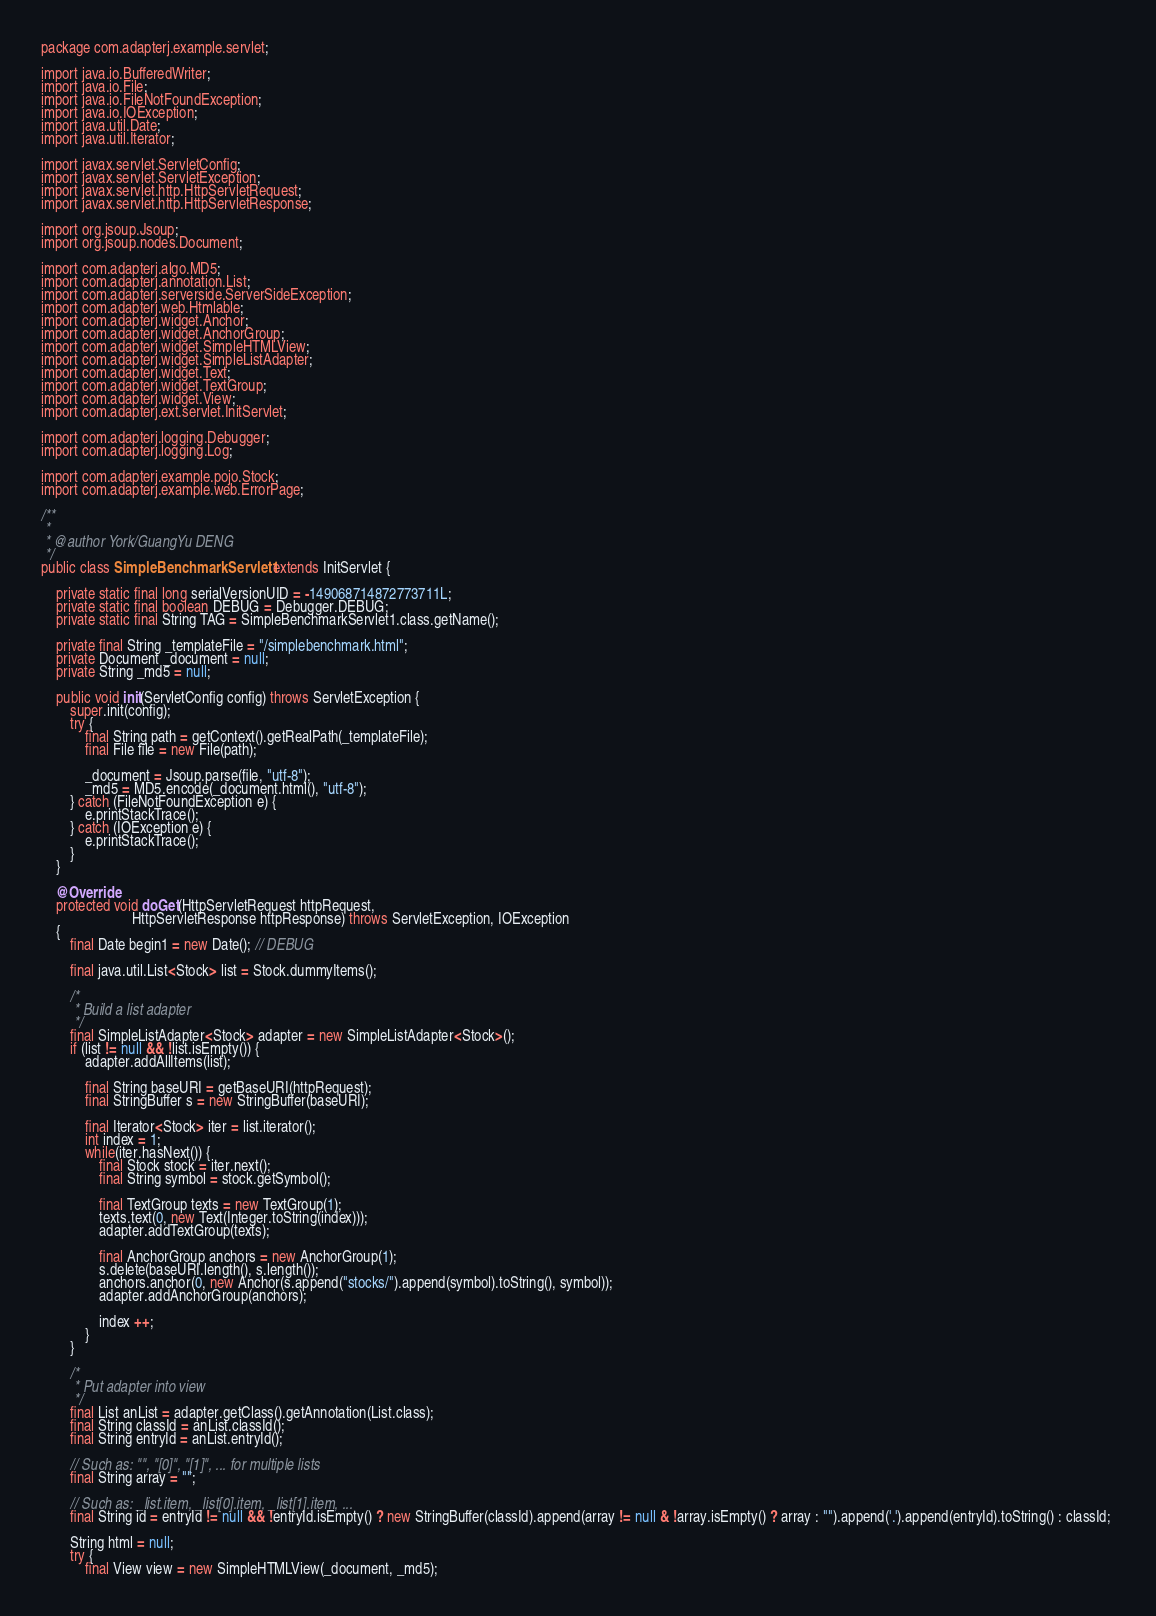Convert code to text. <code><loc_0><loc_0><loc_500><loc_500><_Java_>package com.adapterj.example.servlet;

import java.io.BufferedWriter;
import java.io.File;
import java.io.FileNotFoundException;
import java.io.IOException;
import java.util.Date;
import java.util.Iterator;

import javax.servlet.ServletConfig;
import javax.servlet.ServletException;
import javax.servlet.http.HttpServletRequest;
import javax.servlet.http.HttpServletResponse;

import org.jsoup.Jsoup;
import org.jsoup.nodes.Document;

import com.adapterj.algo.MD5;
import com.adapterj.annotation.List;
import com.adapterj.serverside.ServerSideException;
import com.adapterj.web.Htmlable;
import com.adapterj.widget.Anchor;
import com.adapterj.widget.AnchorGroup;
import com.adapterj.widget.SimpleHTMLView;
import com.adapterj.widget.SimpleListAdapter;
import com.adapterj.widget.Text;
import com.adapterj.widget.TextGroup;
import com.adapterj.widget.View;
import com.adapterj.ext.servlet.InitServlet;

import com.adapterj.logging.Debugger;
import com.adapterj.logging.Log;

import com.adapterj.example.pojo.Stock;
import com.adapterj.example.web.ErrorPage;

/**
 * 
 * @author York/GuangYu DENG
 */
public class SimpleBenchmarkServlet1 extends InitServlet {

	private static final long serialVersionUID = -149068714872773711L;
	private static final boolean DEBUG = Debugger.DEBUG;
    private static final String TAG = SimpleBenchmarkServlet1.class.getName();

    private final String _templateFile = "/simplebenchmark.html";
    private Document _document = null;
    private String _md5 = null;

	public void init(ServletConfig config) throws ServletException {
		super.init(config);
		try {
			final String path = getContext().getRealPath(_templateFile);
			final File file = new File(path);
			
			_document = Jsoup.parse(file, "utf-8");
			_md5 = MD5.encode(_document.html(), "utf-8");
		} catch (FileNotFoundException e) {
			e.printStackTrace();
		} catch (IOException e) {
			e.printStackTrace();
		}
	}

	@Override
	protected void doGet(HttpServletRequest httpRequest, 
						 HttpServletResponse httpResponse) throws ServletException, IOException 
	{
		final Date begin1 = new Date(); // DEBUG

		final java.util.List<Stock> list = Stock.dummyItems();

		/*
		 * Build a list adapter 
		 */
		final SimpleListAdapter<Stock> adapter = new SimpleListAdapter<Stock>();
		if (list != null && !list.isEmpty()) {
			adapter.addAllItems(list);
			
			final String baseURI = getBaseURI(httpRequest);
			final StringBuffer s = new StringBuffer(baseURI);
			
			final Iterator<Stock> iter = list.iterator();
			int index = 1;
			while(iter.hasNext()) {
				final Stock stock = iter.next();
				final String symbol = stock.getSymbol();
				
				final TextGroup texts = new TextGroup(1);
				texts.text(0, new Text(Integer.toString(index)));
				adapter.addTextGroup(texts);
				
				final AnchorGroup anchors = new AnchorGroup(1);
				s.delete(baseURI.length(), s.length());
				anchors.anchor(0, new Anchor(s.append("stocks/").append(symbol).toString(), symbol));
				adapter.addAnchorGroup(anchors);
				
				index ++;
			}
		}
		
		/*
		 * Put adapter into view
		 */
		final List anList = adapter.getClass().getAnnotation(List.class);
		final String classId = anList.classId();
		final String entryId = anList.entryId();
		
		// Such as: "", "[0]", "[1]", ... for multiple lists 
		final String array = "";

		// Such as: _list.item, _list[0].item, _list[1].item, ...
		final String id = entryId != null && !entryId.isEmpty() ? new StringBuffer(classId).append(array != null & !array.isEmpty() ? array : "").append('.').append(entryId).toString() : classId; 
		
		String html = null;
		try {
			final View view = new SimpleHTMLView(_document, _md5);</code> 